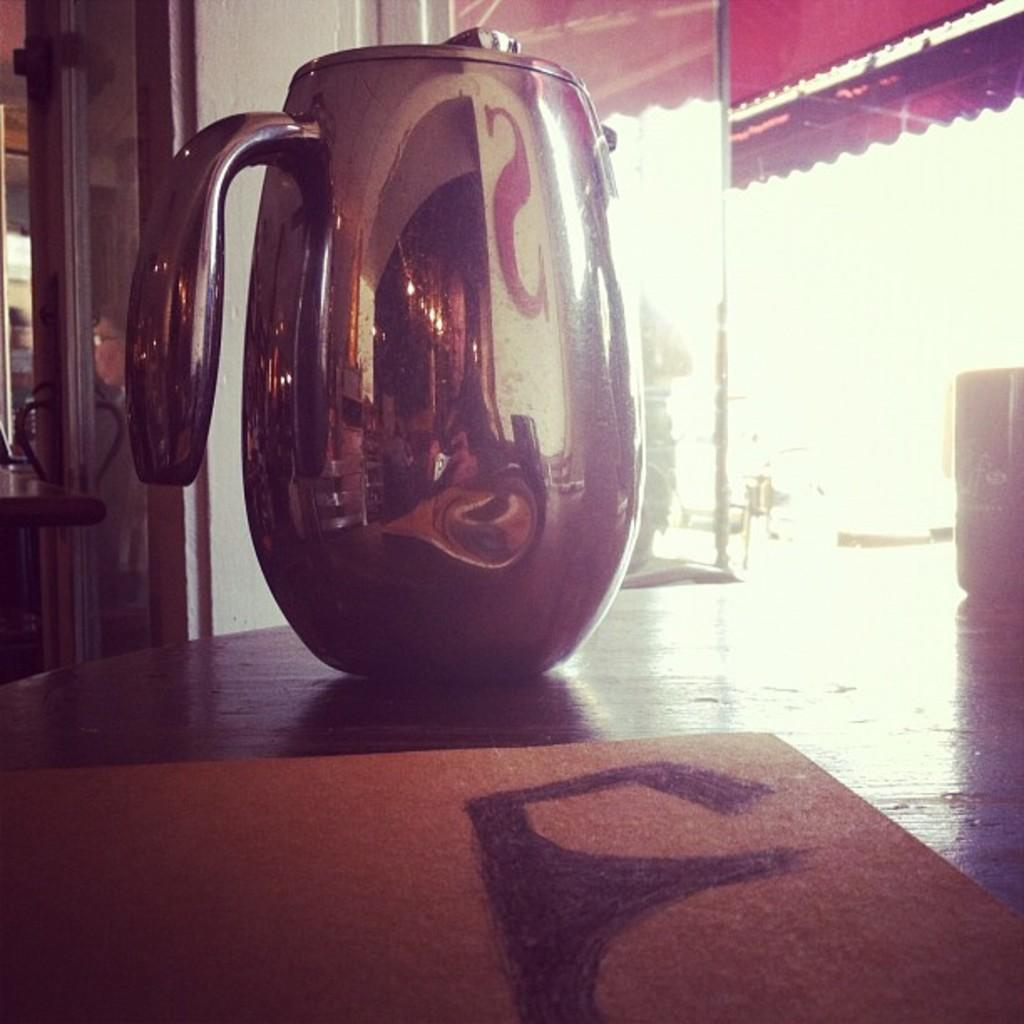What is placed on the wooden table in the image? There is a jar placed on a wooden table in the image. What can be seen in the background of the image? There is a glass door, a tent, and a wall in the background of the image. What type of grain is being added to the jar in the image? There is no grain or addition of any substance to the jar in the image; it is simply a jar placed on a wooden table. Can you see a horse in the image? No, there is no horse present in the image. 